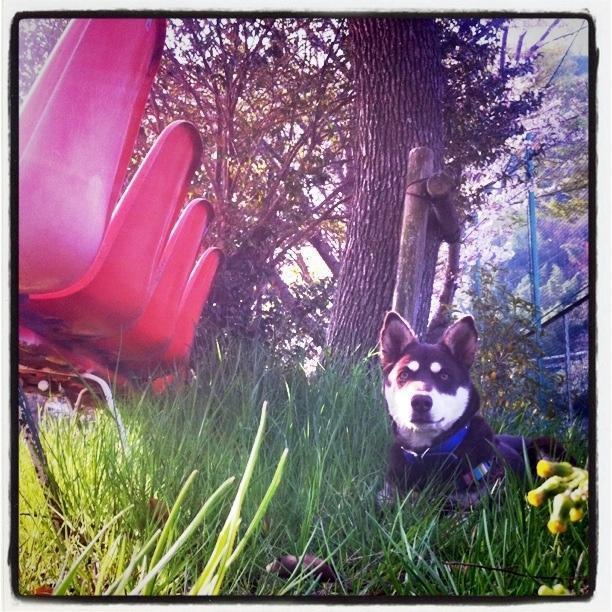What item is in the wrong setting?
Choose the correct response, then elucidate: 'Answer: answer
Rationale: rationale.'
Options: Dog, tree, chairs, grass. Answer: chairs.
Rationale: These are indoor chairs. people normally wouldn't sit in them in the grass. 